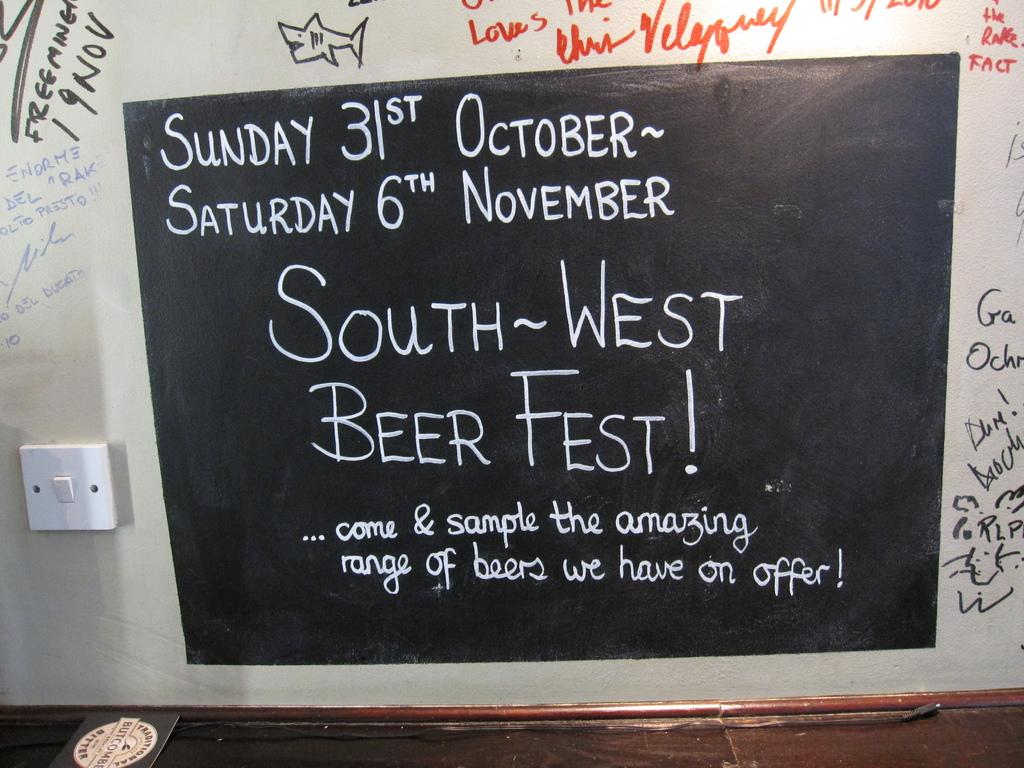<image>
Render a clear and concise summary of the photo. From October 31st through November 6th the South-West Beer Fest will take place. 